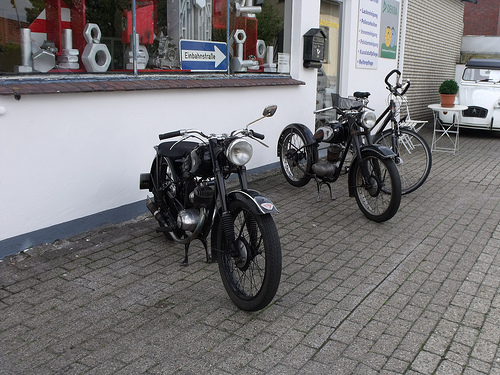<image>
Is the bike to the right of the bicycle? No. The bike is not to the right of the bicycle. The horizontal positioning shows a different relationship. 